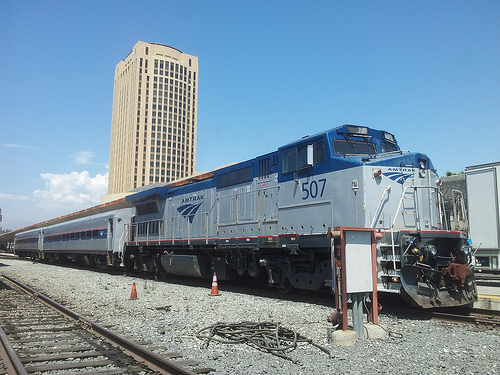<image>
Can you confirm if the train is under the building? No. The train is not positioned under the building. The vertical relationship between these objects is different. 